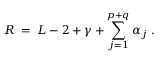Convert formula to latex. <formula><loc_0><loc_0><loc_500><loc_500>R \, = \, L - 2 + \gamma + \sum _ { j = 1 } ^ { p + q } \alpha _ { j } \, .</formula> 